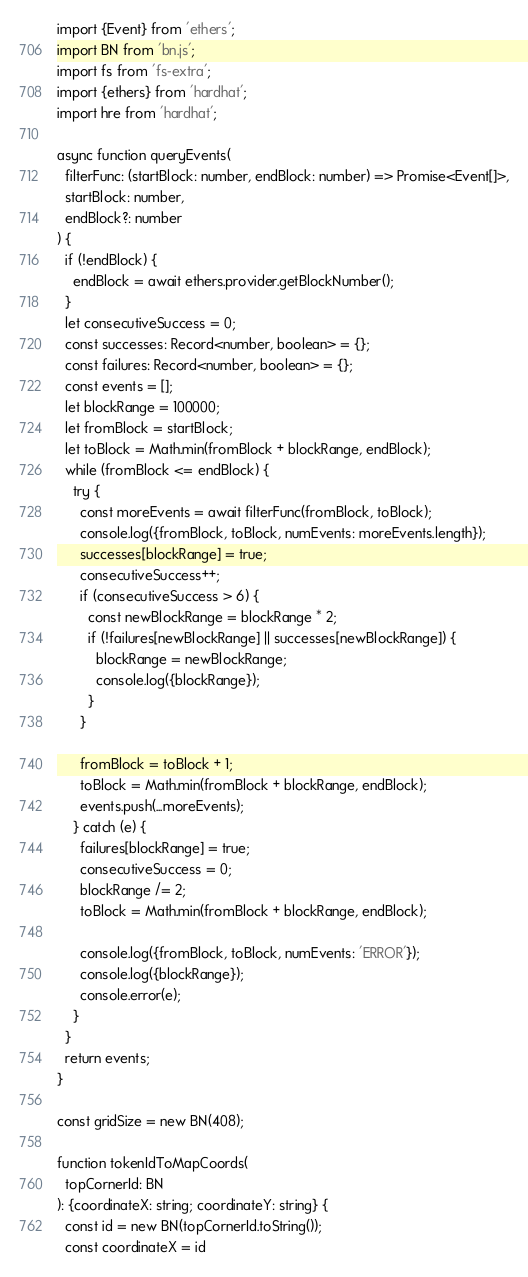Convert code to text. <code><loc_0><loc_0><loc_500><loc_500><_TypeScript_>import {Event} from 'ethers';
import BN from 'bn.js';
import fs from 'fs-extra';
import {ethers} from 'hardhat';
import hre from 'hardhat';

async function queryEvents(
  filterFunc: (startBlock: number, endBlock: number) => Promise<Event[]>,
  startBlock: number,
  endBlock?: number
) {
  if (!endBlock) {
    endBlock = await ethers.provider.getBlockNumber();
  }
  let consecutiveSuccess = 0;
  const successes: Record<number, boolean> = {};
  const failures: Record<number, boolean> = {};
  const events = [];
  let blockRange = 100000;
  let fromBlock = startBlock;
  let toBlock = Math.min(fromBlock + blockRange, endBlock);
  while (fromBlock <= endBlock) {
    try {
      const moreEvents = await filterFunc(fromBlock, toBlock);
      console.log({fromBlock, toBlock, numEvents: moreEvents.length});
      successes[blockRange] = true;
      consecutiveSuccess++;
      if (consecutiveSuccess > 6) {
        const newBlockRange = blockRange * 2;
        if (!failures[newBlockRange] || successes[newBlockRange]) {
          blockRange = newBlockRange;
          console.log({blockRange});
        }
      }

      fromBlock = toBlock + 1;
      toBlock = Math.min(fromBlock + blockRange, endBlock);
      events.push(...moreEvents);
    } catch (e) {
      failures[blockRange] = true;
      consecutiveSuccess = 0;
      blockRange /= 2;
      toBlock = Math.min(fromBlock + blockRange, endBlock);

      console.log({fromBlock, toBlock, numEvents: 'ERROR'});
      console.log({blockRange});
      console.error(e);
    }
  }
  return events;
}

const gridSize = new BN(408);

function tokenIdToMapCoords(
  topCornerId: BN
): {coordinateX: string; coordinateY: string} {
  const id = new BN(topCornerId.toString());
  const coordinateX = id</code> 